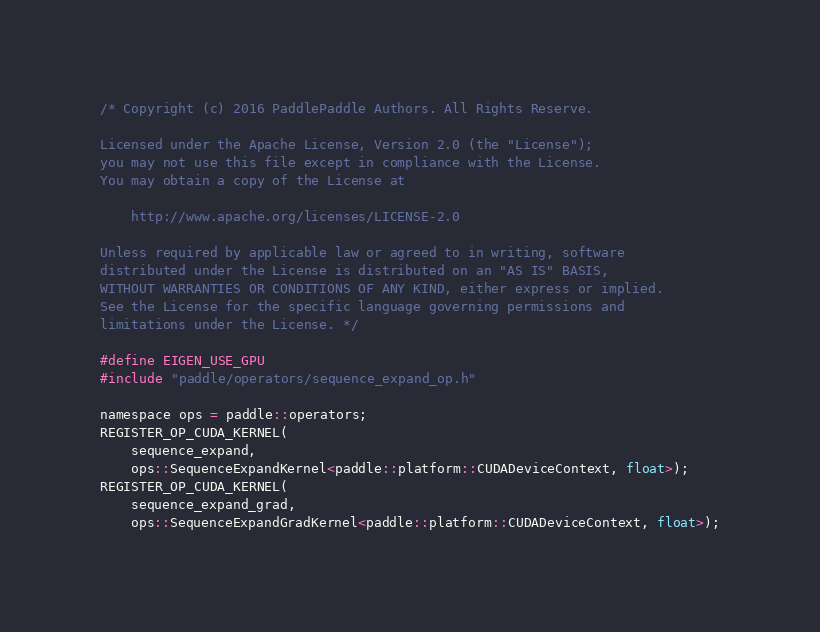Convert code to text. <code><loc_0><loc_0><loc_500><loc_500><_Cuda_>/* Copyright (c) 2016 PaddlePaddle Authors. All Rights Reserve.

Licensed under the Apache License, Version 2.0 (the "License");
you may not use this file except in compliance with the License.
You may obtain a copy of the License at

    http://www.apache.org/licenses/LICENSE-2.0

Unless required by applicable law or agreed to in writing, software
distributed under the License is distributed on an "AS IS" BASIS,
WITHOUT WARRANTIES OR CONDITIONS OF ANY KIND, either express or implied.
See the License for the specific language governing permissions and
limitations under the License. */

#define EIGEN_USE_GPU
#include "paddle/operators/sequence_expand_op.h"

namespace ops = paddle::operators;
REGISTER_OP_CUDA_KERNEL(
    sequence_expand,
    ops::SequenceExpandKernel<paddle::platform::CUDADeviceContext, float>);
REGISTER_OP_CUDA_KERNEL(
    sequence_expand_grad,
    ops::SequenceExpandGradKernel<paddle::platform::CUDADeviceContext, float>);
</code> 